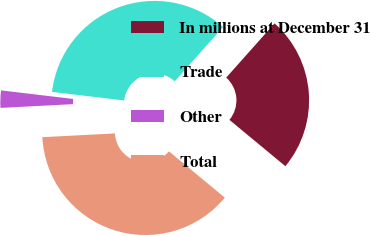<chart> <loc_0><loc_0><loc_500><loc_500><pie_chart><fcel>In millions at December 31<fcel>Trade<fcel>Other<fcel>Total<nl><fcel>24.43%<fcel>34.7%<fcel>2.71%<fcel>38.17%<nl></chart> 